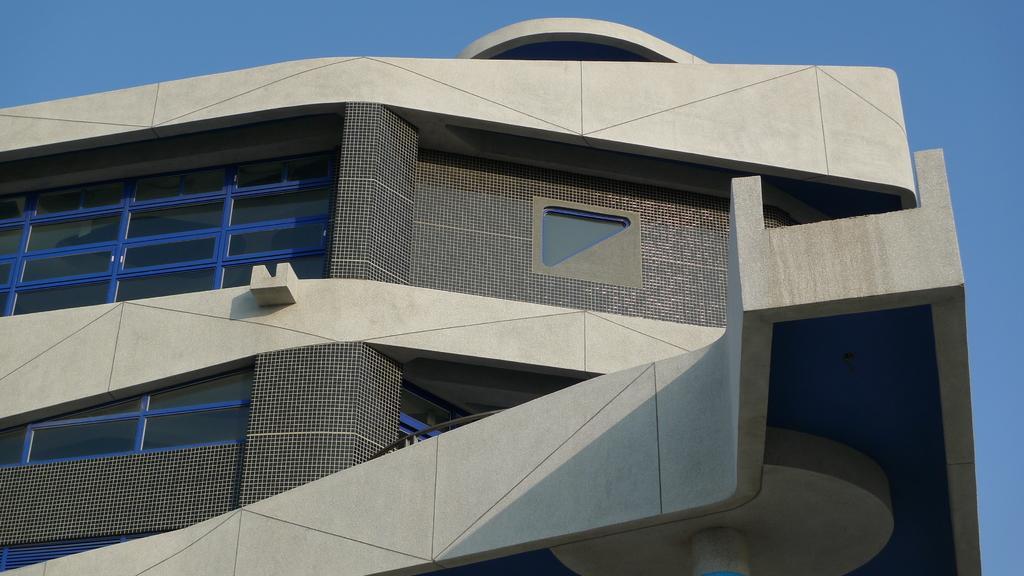Describe this image in one or two sentences. This is a building and a sky. 